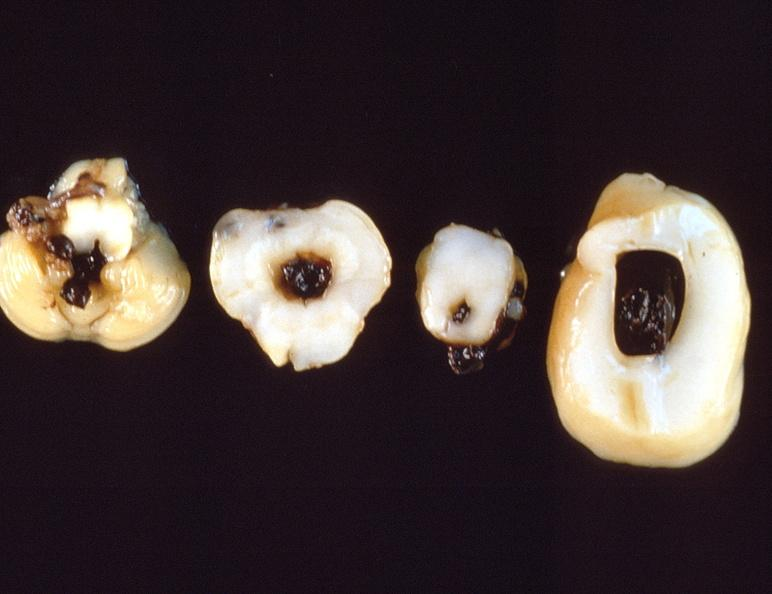s nervous present?
Answer the question using a single word or phrase. Yes 